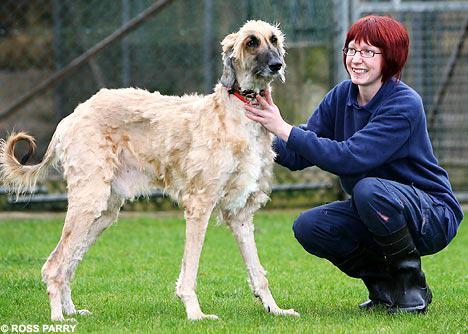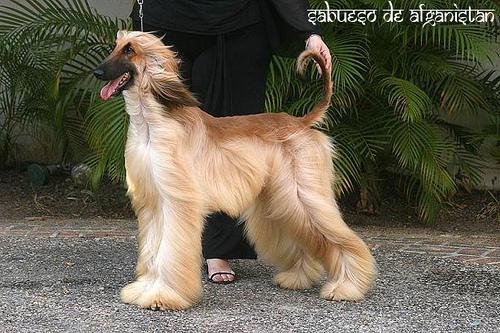The first image is the image on the left, the second image is the image on the right. Examine the images to the left and right. Is the description "The hound on the left is standing and looking forward with its hair combed over one eye, and the hound on the right is standing with its body in profile." accurate? Answer yes or no. No. The first image is the image on the left, the second image is the image on the right. Considering the images on both sides, is "One dog's body is turned to the right, and the other dog's body is turned to the left." valid? Answer yes or no. Yes. 